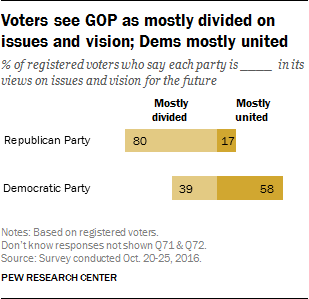Highlight a few significant elements in this photo. The smallest value is of a dark yellow color. The difference between the highest BAE and lowest bar is 0.63. 